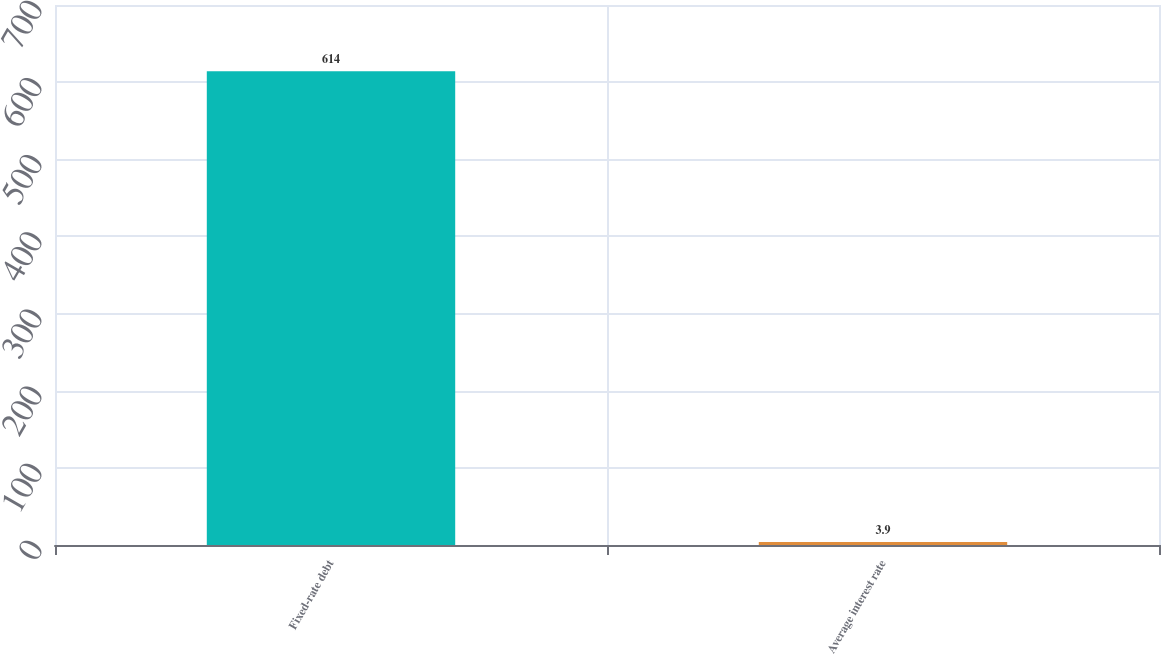Convert chart to OTSL. <chart><loc_0><loc_0><loc_500><loc_500><bar_chart><fcel>Fixed-rate debt<fcel>Average interest rate<nl><fcel>614<fcel>3.9<nl></chart> 